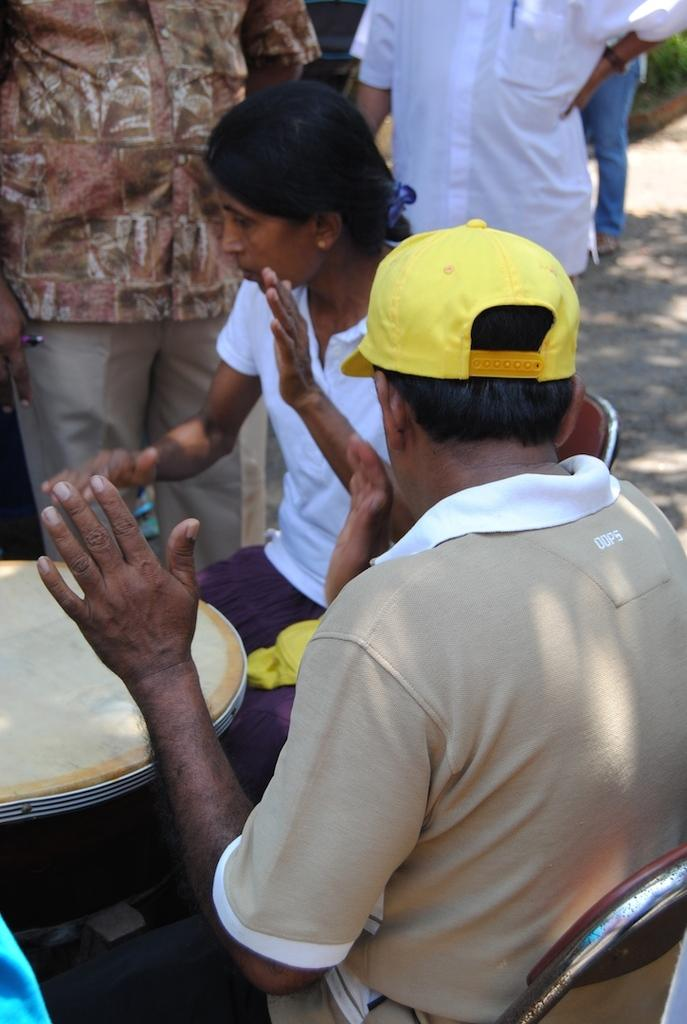How many people are sitting in the image? There are two people sitting in the image. What are the sitting people doing? The two people are playing musical instruments. Can you describe the people in the background of the image? There are three people standing in the background of the image. What type of vegetation is present in the image? There is a plant in the image. What is visible at the bottom of the image? The ground is visible at the bottom of the image. What type of quartz can be seen in the image? There is no quartz present in the image. What type of humor is being displayed by the people in the image? The image does not depict any humor or comedic elements. 